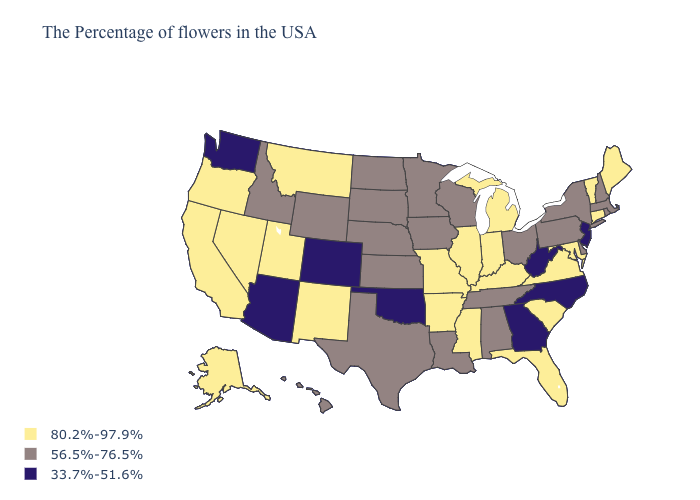Name the states that have a value in the range 80.2%-97.9%?
Quick response, please. Maine, Vermont, Connecticut, Maryland, Virginia, South Carolina, Florida, Michigan, Kentucky, Indiana, Illinois, Mississippi, Missouri, Arkansas, New Mexico, Utah, Montana, Nevada, California, Oregon, Alaska. Among the states that border Oregon , which have the lowest value?
Write a very short answer. Washington. Among the states that border Maryland , does Delaware have the highest value?
Keep it brief. No. What is the value of Maine?
Give a very brief answer. 80.2%-97.9%. Does Illinois have a lower value than North Dakota?
Write a very short answer. No. Which states hav the highest value in the Northeast?
Quick response, please. Maine, Vermont, Connecticut. Does the first symbol in the legend represent the smallest category?
Write a very short answer. No. Which states have the lowest value in the USA?
Be succinct. New Jersey, North Carolina, West Virginia, Georgia, Oklahoma, Colorado, Arizona, Washington. What is the highest value in the USA?
Quick response, please. 80.2%-97.9%. Which states have the lowest value in the West?
Short answer required. Colorado, Arizona, Washington. Which states hav the highest value in the Northeast?
Keep it brief. Maine, Vermont, Connecticut. Does Washington have the lowest value in the USA?
Write a very short answer. Yes. Does Massachusetts have a lower value than Oregon?
Concise answer only. Yes. Does South Carolina have the highest value in the USA?
Short answer required. Yes. What is the value of Idaho?
Quick response, please. 56.5%-76.5%. 